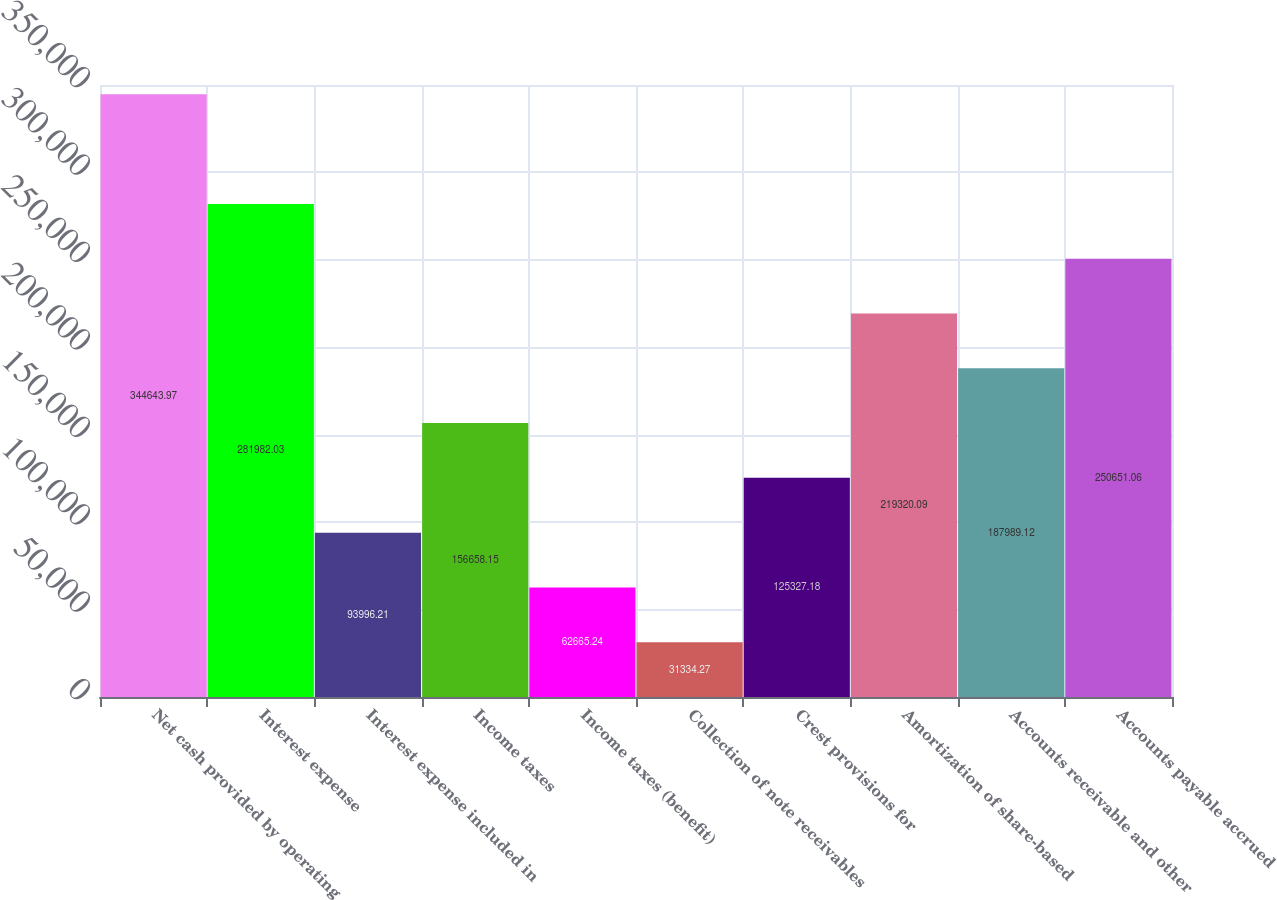Convert chart to OTSL. <chart><loc_0><loc_0><loc_500><loc_500><bar_chart><fcel>Net cash provided by operating<fcel>Interest expense<fcel>Interest expense included in<fcel>Income taxes<fcel>Income taxes (benefit)<fcel>Collection of note receivables<fcel>Crest provisions for<fcel>Amortization of share-based<fcel>Accounts receivable and other<fcel>Accounts payable accrued<nl><fcel>344644<fcel>281982<fcel>93996.2<fcel>156658<fcel>62665.2<fcel>31334.3<fcel>125327<fcel>219320<fcel>187989<fcel>250651<nl></chart> 